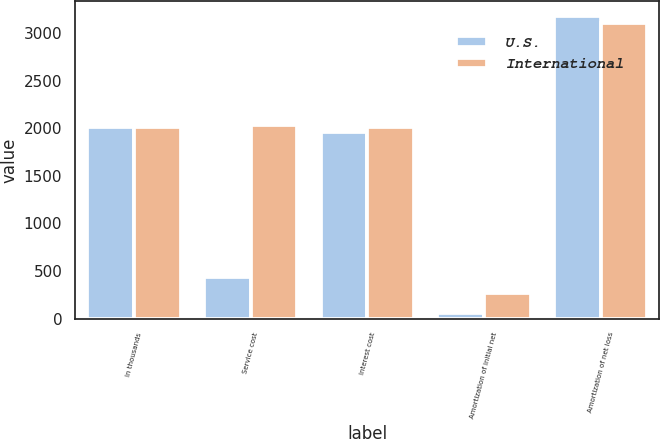Convert chart. <chart><loc_0><loc_0><loc_500><loc_500><stacked_bar_chart><ecel><fcel>In thousands<fcel>Service cost<fcel>Interest cost<fcel>Amortization of initial net<fcel>Amortization of net loss<nl><fcel>U.S.<fcel>2013<fcel>432<fcel>1960<fcel>62<fcel>3180<nl><fcel>International<fcel>2013<fcel>2035<fcel>2013<fcel>270<fcel>3107<nl></chart> 